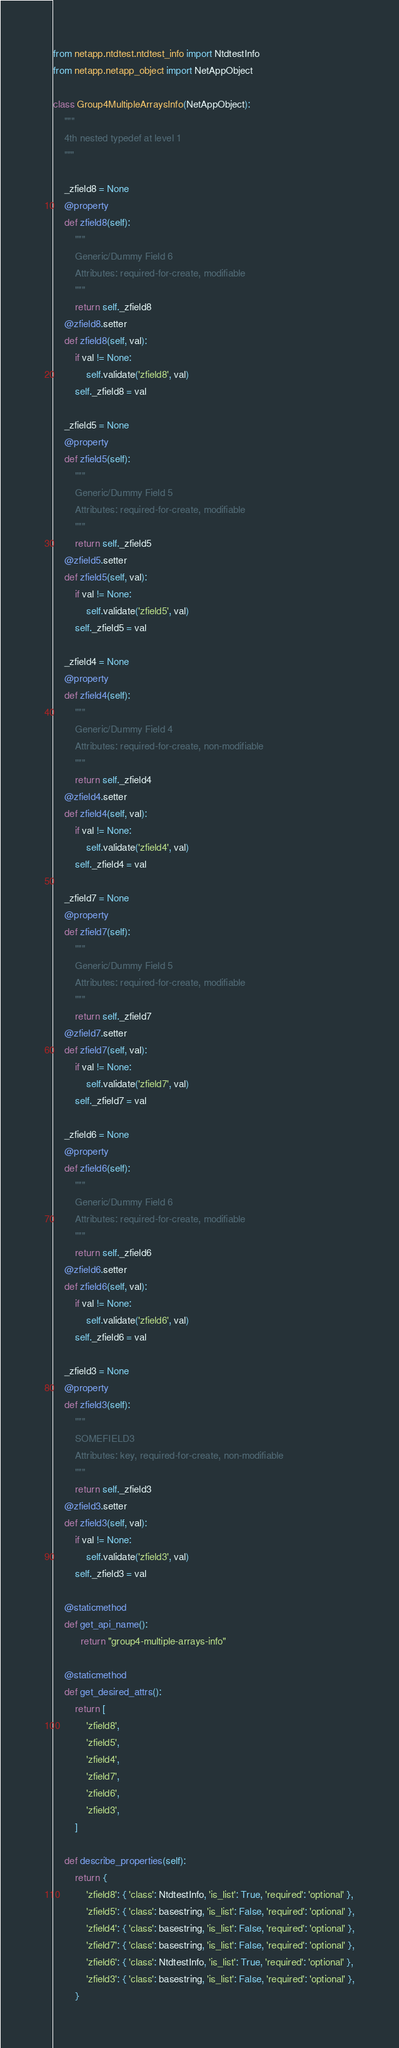<code> <loc_0><loc_0><loc_500><loc_500><_Python_>from netapp.ntdtest.ntdtest_info import NtdtestInfo
from netapp.netapp_object import NetAppObject

class Group4MultipleArraysInfo(NetAppObject):
    """
    4th nested typedef at level 1
    """
    
    _zfield8 = None
    @property
    def zfield8(self):
        """
        Generic/Dummy Field 6
        Attributes: required-for-create, modifiable
        """
        return self._zfield8
    @zfield8.setter
    def zfield8(self, val):
        if val != None:
            self.validate('zfield8', val)
        self._zfield8 = val
    
    _zfield5 = None
    @property
    def zfield5(self):
        """
        Generic/Dummy Field 5
        Attributes: required-for-create, modifiable
        """
        return self._zfield5
    @zfield5.setter
    def zfield5(self, val):
        if val != None:
            self.validate('zfield5', val)
        self._zfield5 = val
    
    _zfield4 = None
    @property
    def zfield4(self):
        """
        Generic/Dummy Field 4
        Attributes: required-for-create, non-modifiable
        """
        return self._zfield4
    @zfield4.setter
    def zfield4(self, val):
        if val != None:
            self.validate('zfield4', val)
        self._zfield4 = val
    
    _zfield7 = None
    @property
    def zfield7(self):
        """
        Generic/Dummy Field 5
        Attributes: required-for-create, modifiable
        """
        return self._zfield7
    @zfield7.setter
    def zfield7(self, val):
        if val != None:
            self.validate('zfield7', val)
        self._zfield7 = val
    
    _zfield6 = None
    @property
    def zfield6(self):
        """
        Generic/Dummy Field 6
        Attributes: required-for-create, modifiable
        """
        return self._zfield6
    @zfield6.setter
    def zfield6(self, val):
        if val != None:
            self.validate('zfield6', val)
        self._zfield6 = val
    
    _zfield3 = None
    @property
    def zfield3(self):
        """
        SOMEFIELD3
        Attributes: key, required-for-create, non-modifiable
        """
        return self._zfield3
    @zfield3.setter
    def zfield3(self, val):
        if val != None:
            self.validate('zfield3', val)
        self._zfield3 = val
    
    @staticmethod
    def get_api_name():
          return "group4-multiple-arrays-info"
    
    @staticmethod
    def get_desired_attrs():
        return [
            'zfield8',
            'zfield5',
            'zfield4',
            'zfield7',
            'zfield6',
            'zfield3',
        ]
    
    def describe_properties(self):
        return {
            'zfield8': { 'class': NtdtestInfo, 'is_list': True, 'required': 'optional' },
            'zfield5': { 'class': basestring, 'is_list': False, 'required': 'optional' },
            'zfield4': { 'class': basestring, 'is_list': False, 'required': 'optional' },
            'zfield7': { 'class': basestring, 'is_list': False, 'required': 'optional' },
            'zfield6': { 'class': NtdtestInfo, 'is_list': True, 'required': 'optional' },
            'zfield3': { 'class': basestring, 'is_list': False, 'required': 'optional' },
        }
</code> 